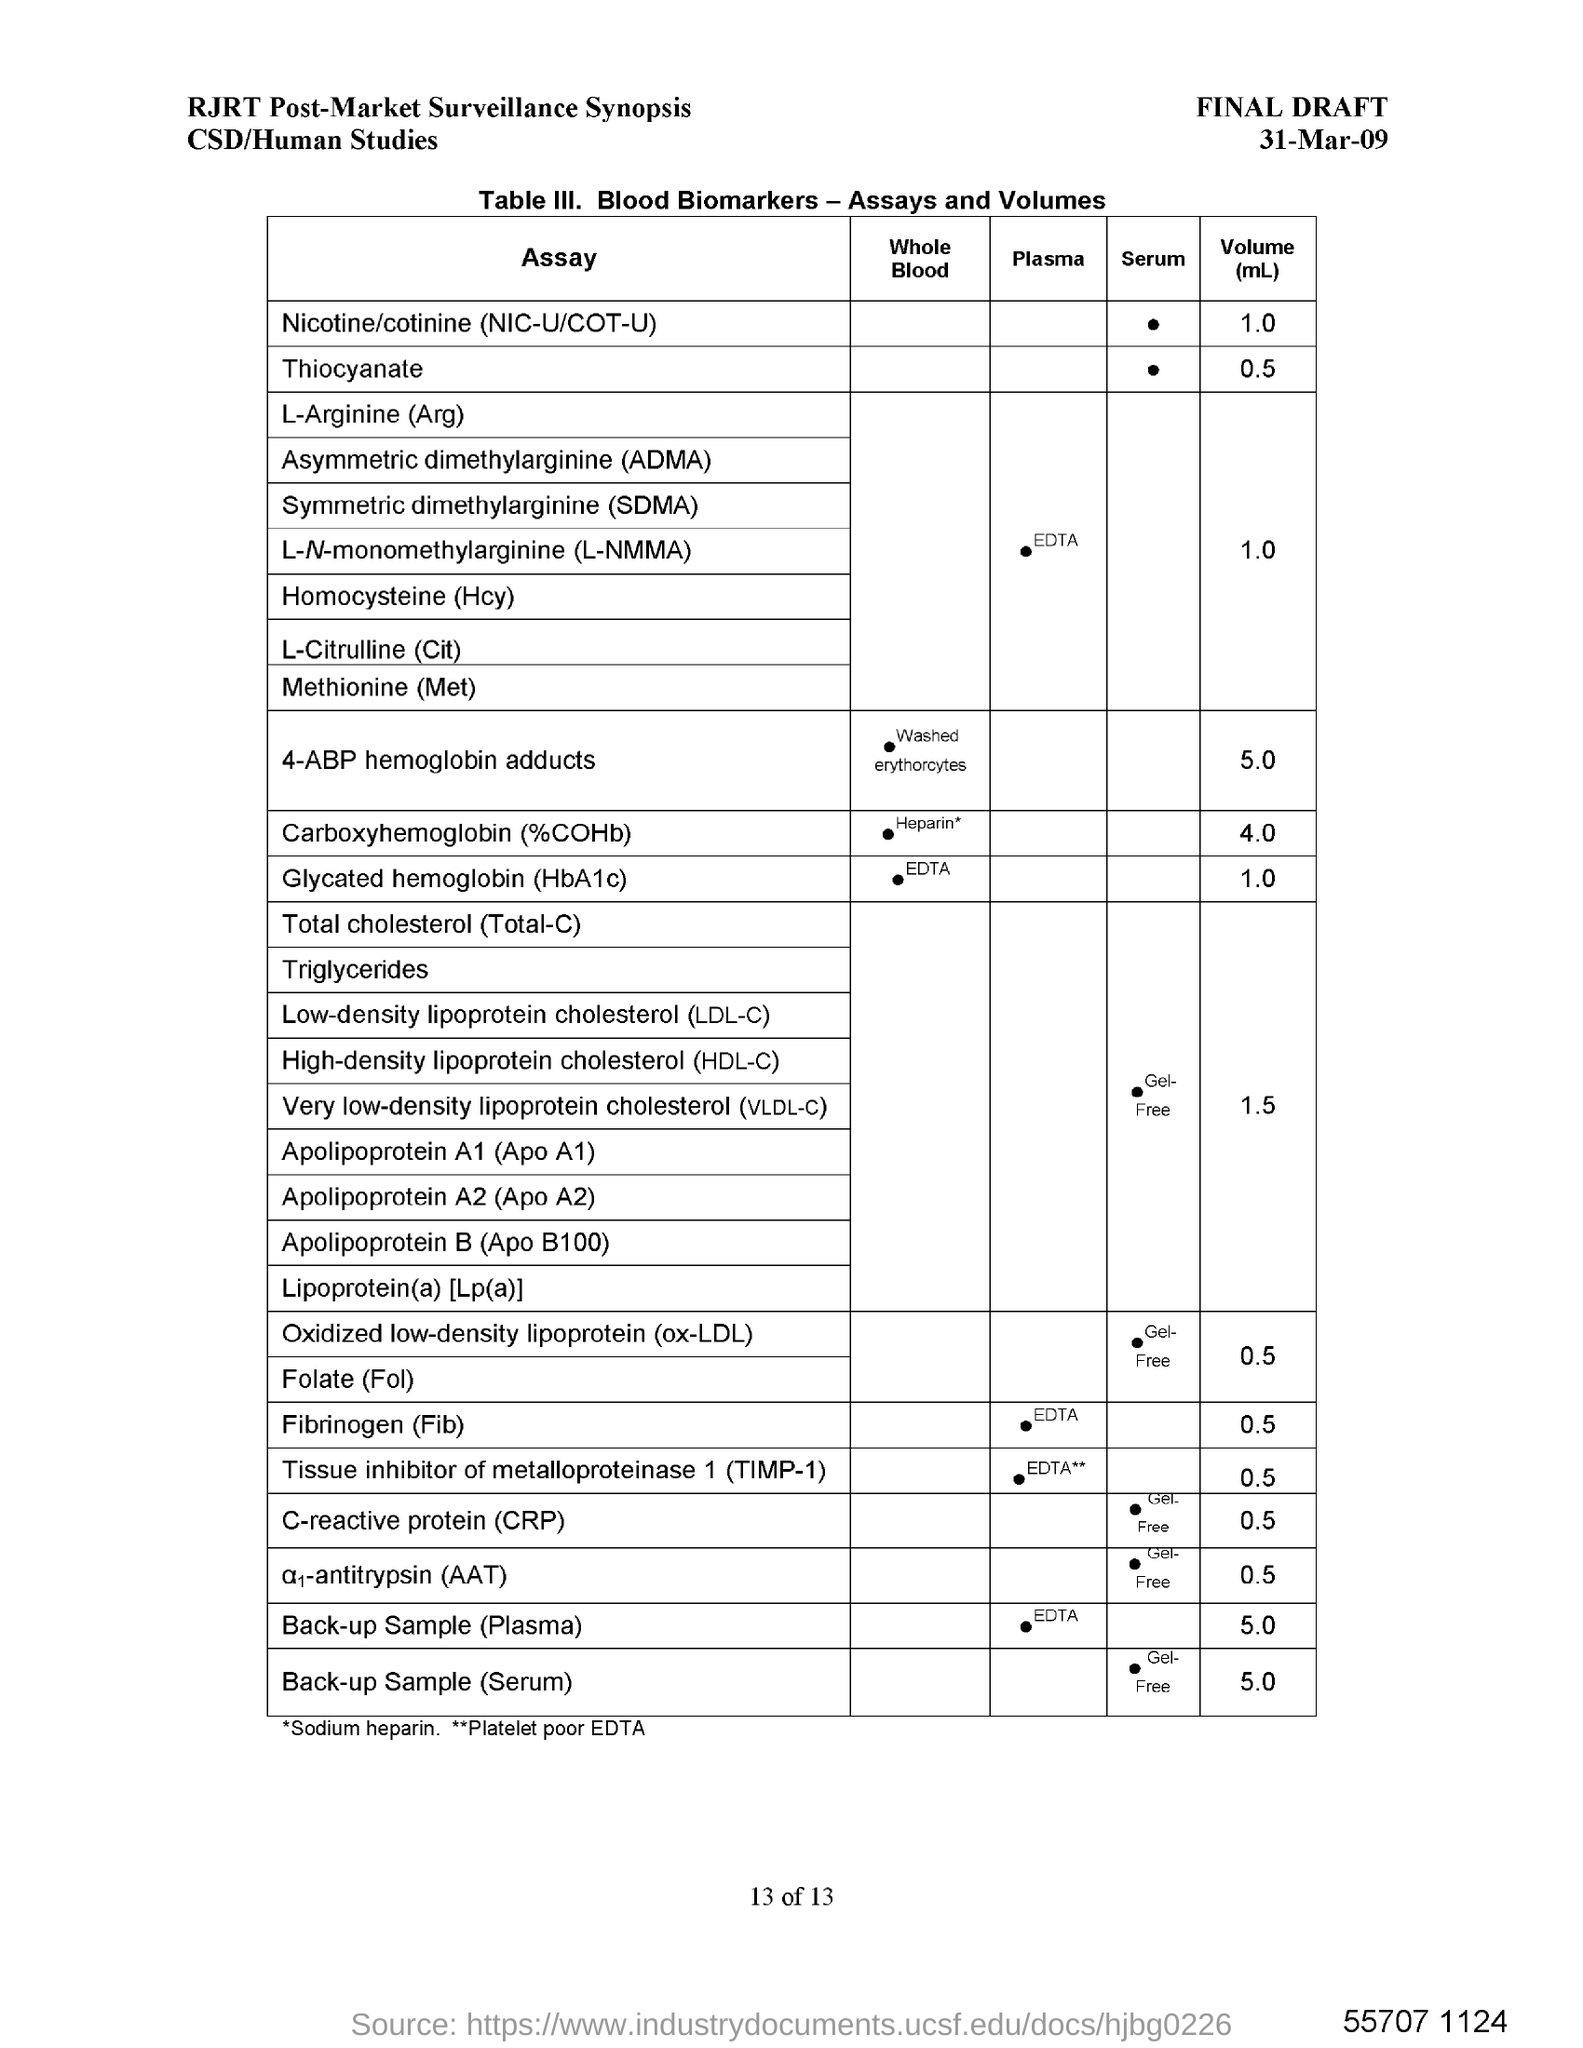Mention a couple of crucial points in this snapshot. The date mentioned in the document is March 31, 2009. 